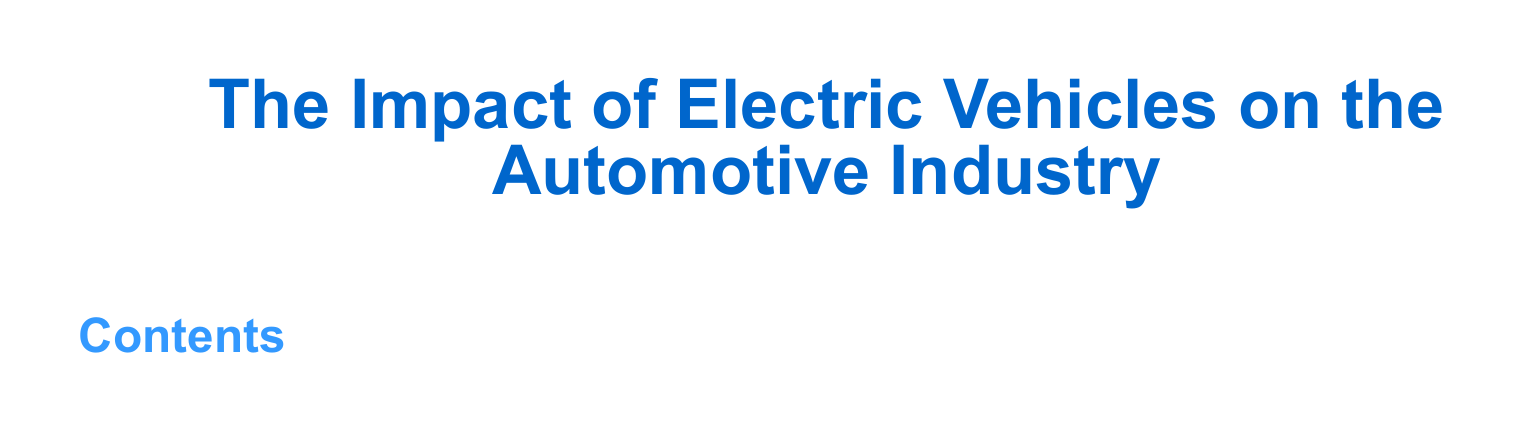What is the title of the document? The title is presented prominently at the beginning of the document.
Answer: The Impact of Electric Vehicles on the Automotive Industry How is the document organized? The document is organized into sections, as indicated by the Table of Contents.
Answer: Sections What color is used for the title? The color of the title is specified in the document's code.
Answer: RGB(0,102,204) What font is used in the document? The main font is set at the beginning of the document.
Answer: Arial Is there a margin specified in the document? The margin settings are defined in the document code.
Answer: 1 cm How many columns are used in the Table of Contents? The number of columns in the Table of Contents is indicated in the document setup.
Answer: 2 What type of document is this? The structure and features identify the nature of the document.
Answer: Article What is the main styling feature of section titles? The styling characteristics for section titles are defined in the document.
Answer: Color and bold font What is the main purpose of this document? The purpose can be inferred from the title of the document.
Answer: To analyze the impact of electric vehicles 